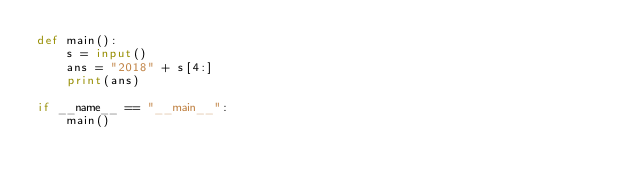Convert code to text. <code><loc_0><loc_0><loc_500><loc_500><_Python_>def main():
    s = input()
    ans = "2018" + s[4:]
    print(ans)

if __name__ == "__main__":
    main()</code> 